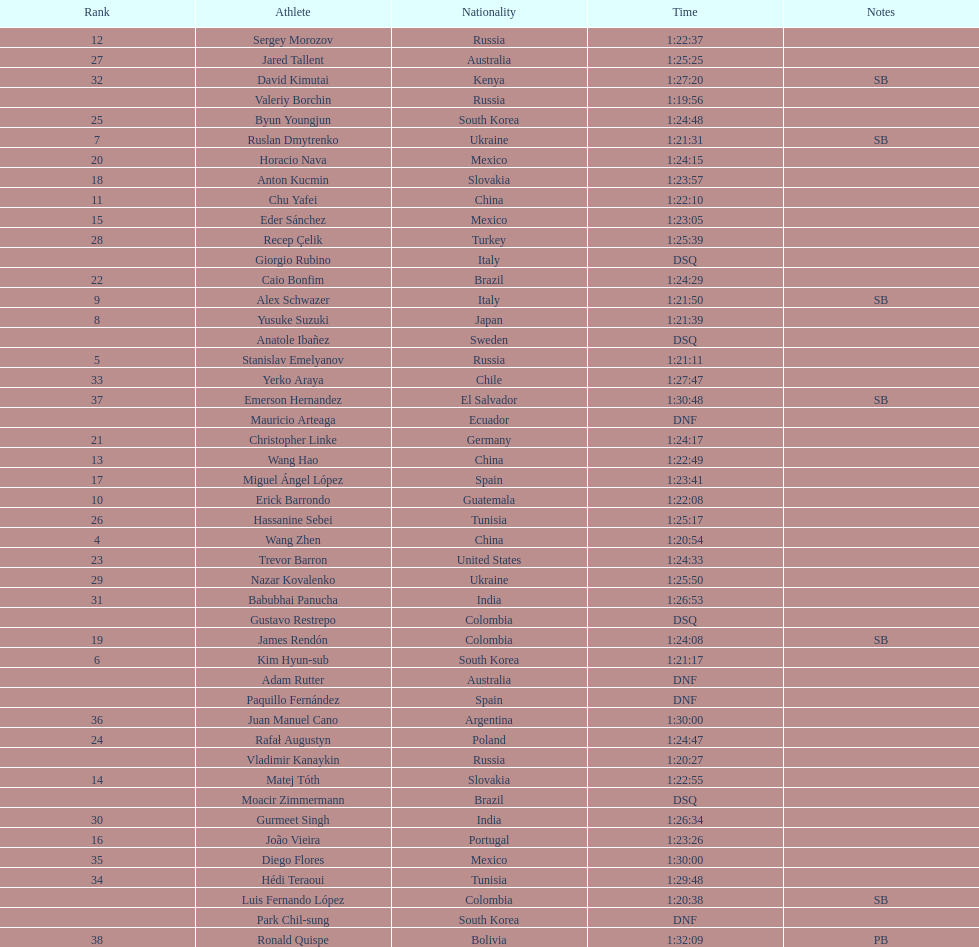How many competitors were from russia? 4. 